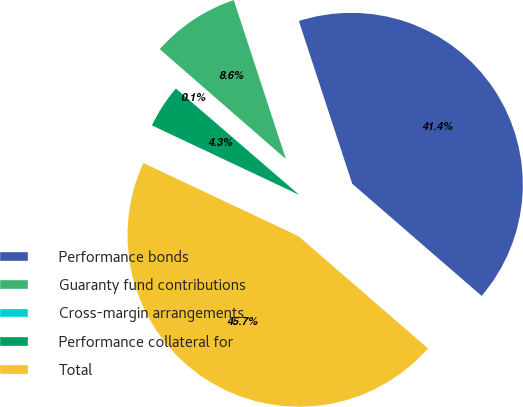Convert chart. <chart><loc_0><loc_0><loc_500><loc_500><pie_chart><fcel>Performance bonds<fcel>Guaranty fund contributions<fcel>Cross-margin arrangements<fcel>Performance collateral for<fcel>Total<nl><fcel>41.41%<fcel>8.55%<fcel>0.08%<fcel>4.31%<fcel>45.65%<nl></chart> 